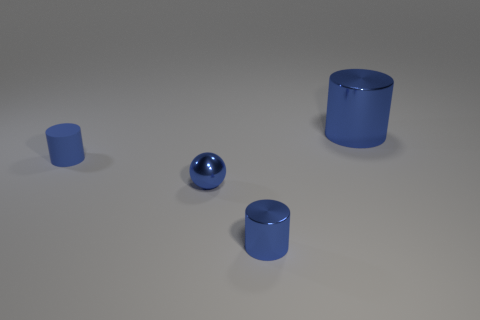There is a metallic cylinder that is left of the big blue metallic thing; does it have the same color as the metallic ball?
Offer a terse response. Yes. The large thing has what color?
Ensure brevity in your answer.  Blue. There is a blue metal cylinder that is in front of the big cylinder; is there a matte cylinder that is on the right side of it?
Your answer should be compact. No. There is a blue thing behind the blue matte thing that is to the left of the tiny sphere; what is its shape?
Provide a succinct answer. Cylinder. Is the number of large shiny things less than the number of big red matte objects?
Your answer should be very brief. No. Is the big blue thing made of the same material as the blue ball?
Make the answer very short. Yes. The cylinder that is in front of the large blue cylinder and on the right side of the blue rubber cylinder is what color?
Your answer should be very brief. Blue. Is there a blue metallic ball that has the same size as the rubber object?
Make the answer very short. Yes. How big is the blue shiny cylinder that is behind the blue metallic cylinder in front of the large blue cylinder?
Keep it short and to the point. Large. Is the number of things to the right of the small blue sphere less than the number of matte cylinders?
Keep it short and to the point. No. 